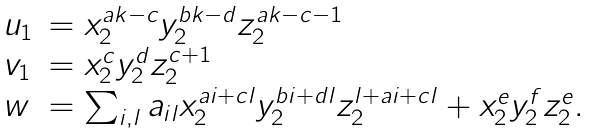Convert formula to latex. <formula><loc_0><loc_0><loc_500><loc_500>\begin{array} { l l } u _ { 1 } & = x _ { 2 } ^ { a k - c } y _ { 2 } ^ { b k - d } z _ { 2 } ^ { a k - c - 1 } \\ v _ { 1 } & = x _ { 2 } ^ { c } y _ { 2 } ^ { d } z _ { 2 } ^ { c + 1 } \\ w & = \sum _ { i , l } a _ { i l } x _ { 2 } ^ { a i + c l } y _ { 2 } ^ { b i + d l } z _ { 2 } ^ { l + a i + c l } + x _ { 2 } ^ { e } y _ { 2 } ^ { f } z _ { 2 } ^ { e } . \end{array}</formula> 